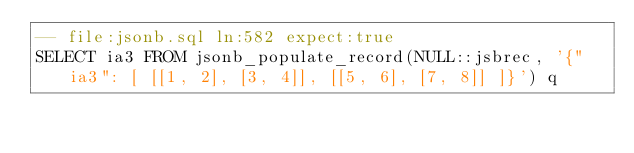<code> <loc_0><loc_0><loc_500><loc_500><_SQL_>-- file:jsonb.sql ln:582 expect:true
SELECT ia3 FROM jsonb_populate_record(NULL::jsbrec, '{"ia3": [ [[1, 2], [3, 4]], [[5, 6], [7, 8]] ]}') q
</code> 